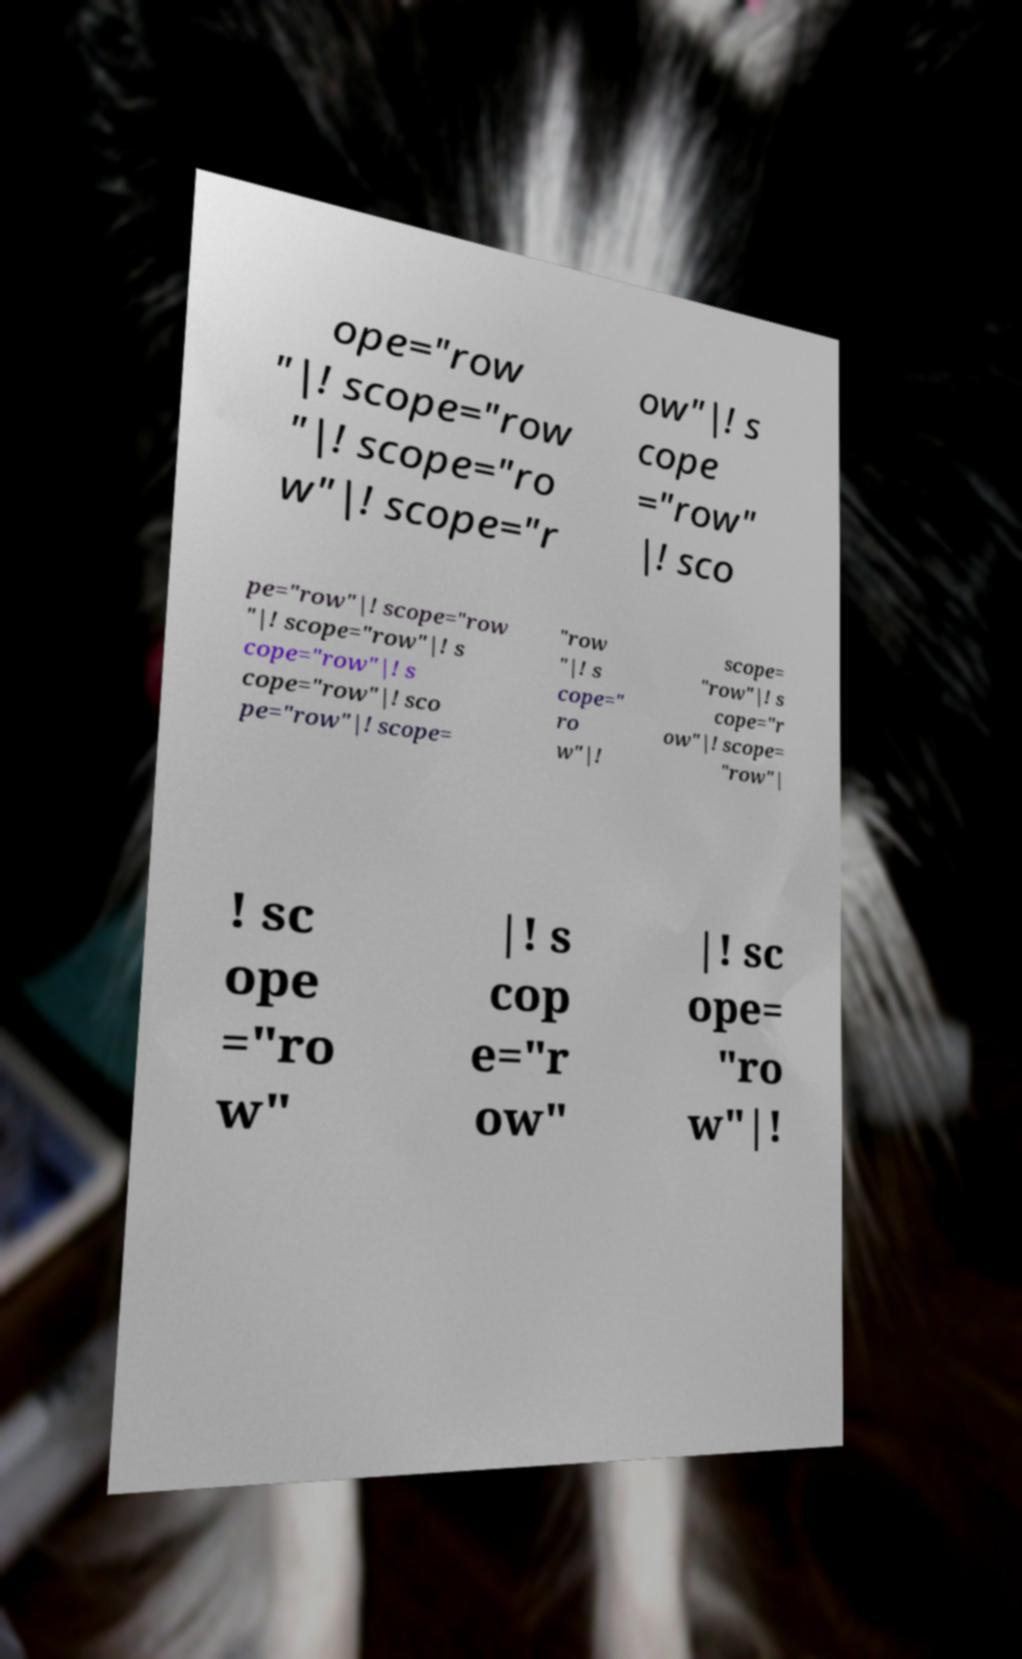Could you assist in decoding the text presented in this image and type it out clearly? ope="row "|! scope="row "|! scope="ro w"|! scope="r ow"|! s cope ="row" |! sco pe="row"|! scope="row "|! scope="row"|! s cope="row"|! s cope="row"|! sco pe="row"|! scope= "row "|! s cope=" ro w"|! scope= "row"|! s cope="r ow"|! scope= "row"| ! sc ope ="ro w" |! s cop e="r ow" |! sc ope= "ro w"|! 